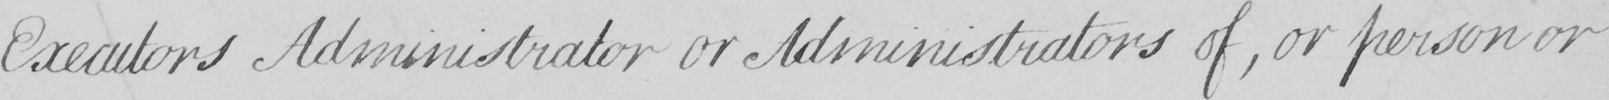What text is written in this handwritten line? Executors Administrator or Administrators of , or person or 